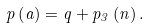Convert formula to latex. <formula><loc_0><loc_0><loc_500><loc_500>p \left ( a \right ) = q + p _ { 3 } \left ( n \right ) .</formula> 